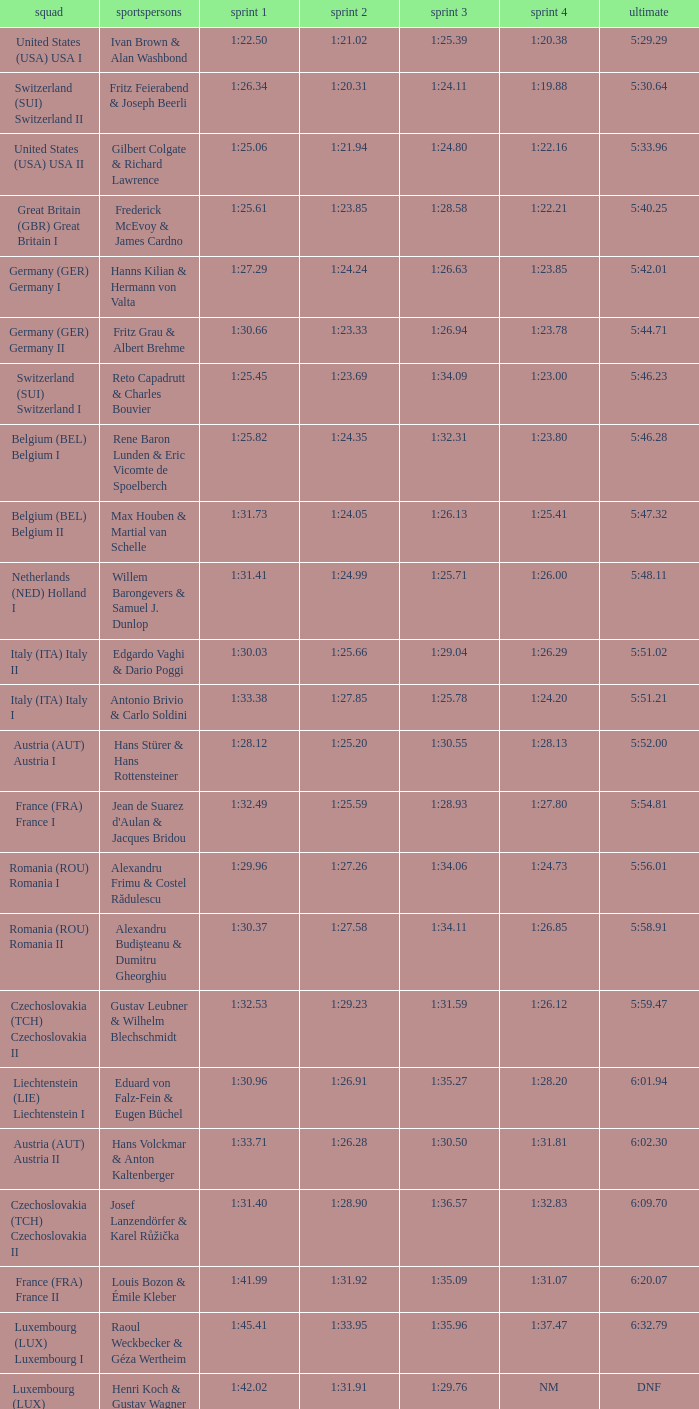Which Run 2 has a Run 1 of 1:30.03? 1:25.66. 